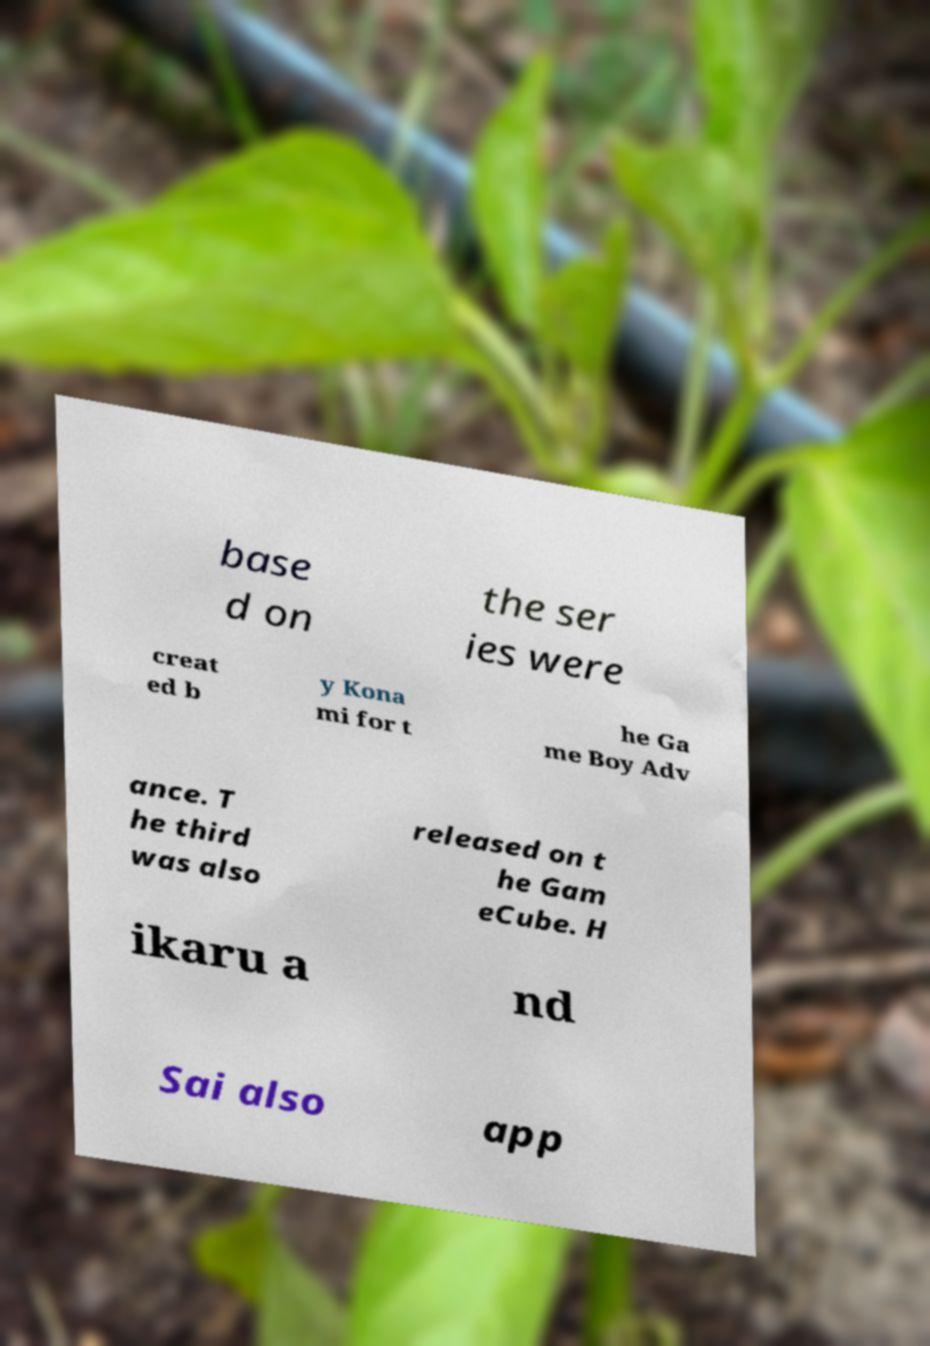For documentation purposes, I need the text within this image transcribed. Could you provide that? base d on the ser ies were creat ed b y Kona mi for t he Ga me Boy Adv ance. T he third was also released on t he Gam eCube. H ikaru a nd Sai also app 